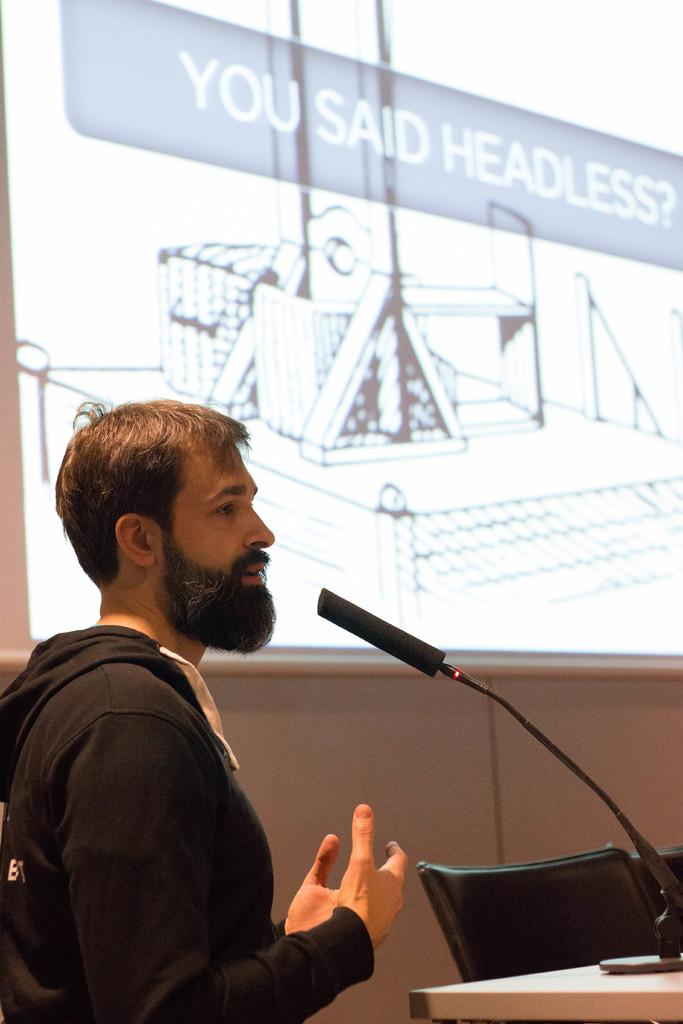What is the main subject of the image? There is a person standing in the image. What object is visible near the person? There is a microphone in the image. What type of furniture is present in the image? There are chairs in the image. What large surface is visible in the background? There is a projector screen in the image. How far does the person need to swim to reach the microphone? There is no swimming involved in the image, as the person is standing near the microphone. 